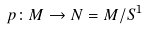Convert formula to latex. <formula><loc_0><loc_0><loc_500><loc_500>p \colon M \rightarrow N = M / S ^ { 1 }</formula> 